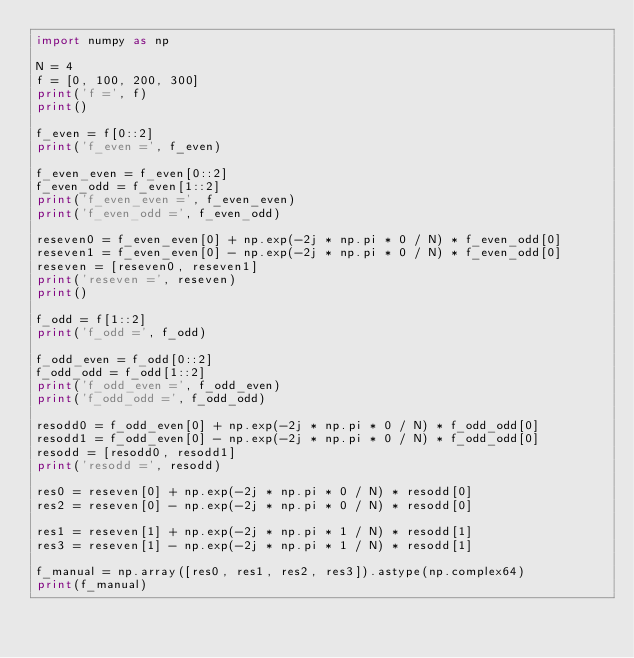Convert code to text. <code><loc_0><loc_0><loc_500><loc_500><_Python_>import numpy as np

N = 4
f = [0, 100, 200, 300]
print('f =', f)
print()

f_even = f[0::2]
print('f_even =', f_even)

f_even_even = f_even[0::2]
f_even_odd = f_even[1::2]
print('f_even_even =', f_even_even)
print('f_even_odd =', f_even_odd)

reseven0 = f_even_even[0] + np.exp(-2j * np.pi * 0 / N) * f_even_odd[0]
reseven1 = f_even_even[0] - np.exp(-2j * np.pi * 0 / N) * f_even_odd[0]
reseven = [reseven0, reseven1]
print('reseven =', reseven)
print()

f_odd = f[1::2]
print('f_odd =', f_odd)

f_odd_even = f_odd[0::2]
f_odd_odd = f_odd[1::2]
print('f_odd_even =', f_odd_even)
print('f_odd_odd =', f_odd_odd)

resodd0 = f_odd_even[0] + np.exp(-2j * np.pi * 0 / N) * f_odd_odd[0]
resodd1 = f_odd_even[0] - np.exp(-2j * np.pi * 0 / N) * f_odd_odd[0]
resodd = [resodd0, resodd1]
print('resodd =', resodd)

res0 = reseven[0] + np.exp(-2j * np.pi * 0 / N) * resodd[0]
res2 = reseven[0] - np.exp(-2j * np.pi * 0 / N) * resodd[0]

res1 = reseven[1] + np.exp(-2j * np.pi * 1 / N) * resodd[1]
res3 = reseven[1] - np.exp(-2j * np.pi * 1 / N) * resodd[1]

f_manual = np.array([res0, res1, res2, res3]).astype(np.complex64)
print(f_manual)
</code> 